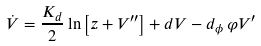Convert formula to latex. <formula><loc_0><loc_0><loc_500><loc_500>\dot { V } = \frac { K _ { d } } { 2 } \ln \left [ z + V ^ { \prime \prime } \right ] + d V - d _ { \phi } \, \varphi V ^ { \prime }</formula> 